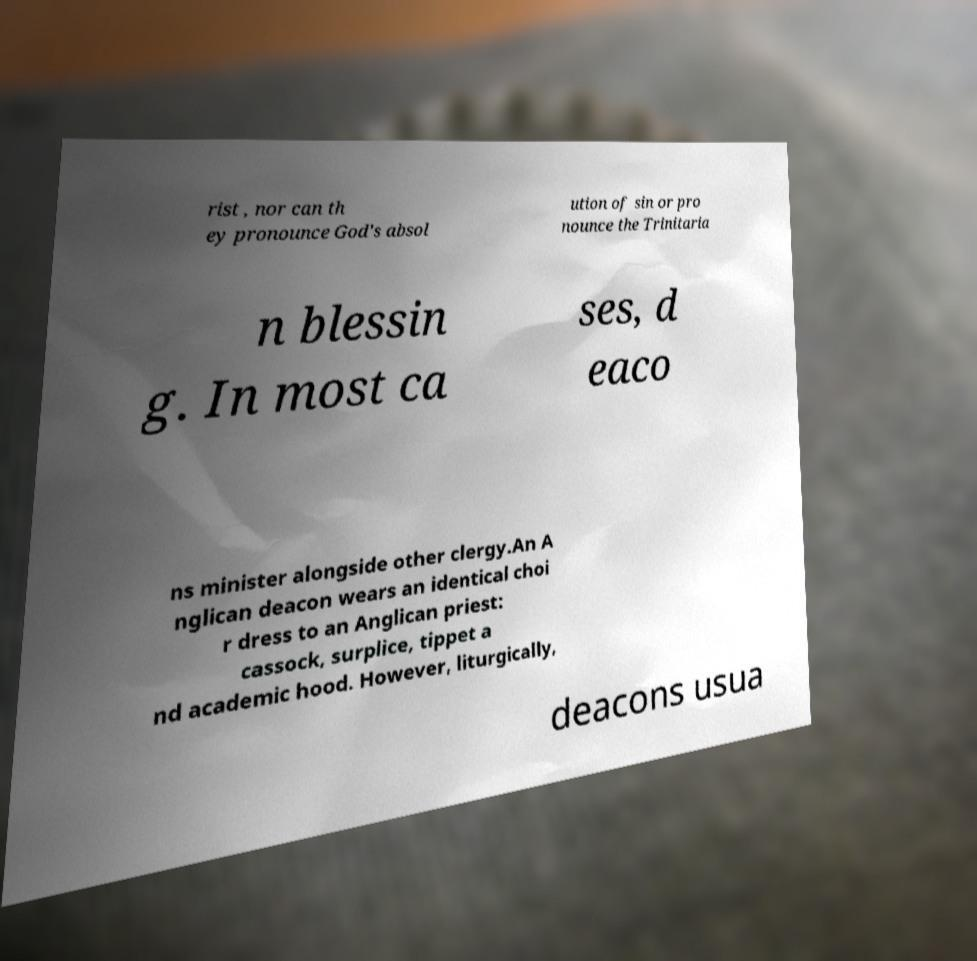Please read and relay the text visible in this image. What does it say? rist , nor can th ey pronounce God's absol ution of sin or pro nounce the Trinitaria n blessin g. In most ca ses, d eaco ns minister alongside other clergy.An A nglican deacon wears an identical choi r dress to an Anglican priest: cassock, surplice, tippet a nd academic hood. However, liturgically, deacons usua 